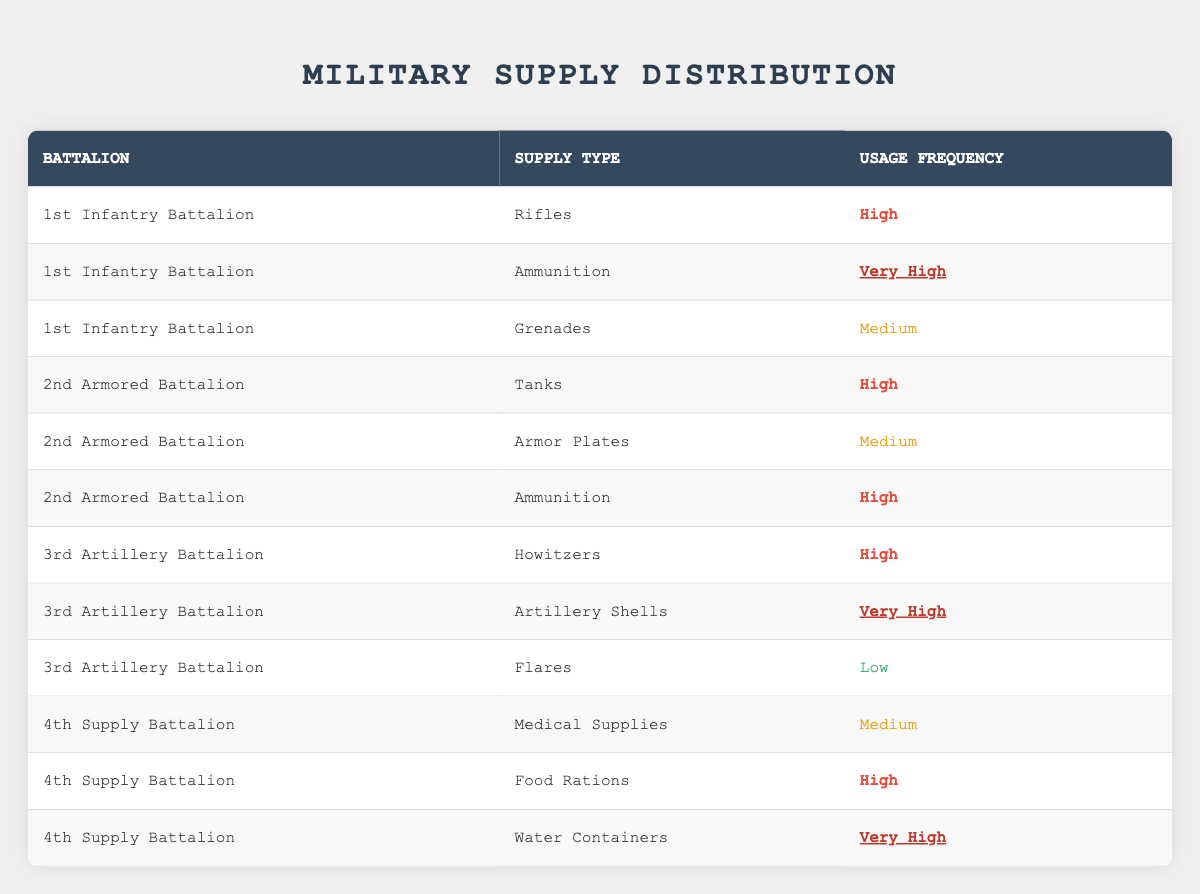What is the usage frequency of ammunition in the 1st Infantry Battalion? Looking at the table, the 1st Infantry Battalion has ammunition listed with a usage frequency marked as "Very High."
Answer: Very High How many different supply types are listed for the 2nd Armored Battalion? The 2nd Armored Battalion has three different supply types: Tanks, Armor Plates, and Ammunition, as seen in the table.
Answer: 3 Is there any supply type with a usage frequency labeled as "Low"? Yes, the 3rd Artillery Battalion has Flares listed with a usage frequency of "Low" in the table.
Answer: Yes How many battalions have high usage frequency for their supplies? Reviewing the table, the battalions with high usage frequency are the 1st Infantry Battalion (Rifles), 2nd Armored Battalion (Tanks and Ammunition), 3rd Artillery Battalion (Howitzers), and 4th Supply Battalion (Food Rations). This makes a total of 5 instances of high usage across 4 battalions.
Answer: 4 Which battalion uses "Water Containers" and what is its usage frequency? From the table, the 4th Supply Battalion uses "Water Containers," and the usage frequency is classified as "Very High." This information can be directly referenced in the table.
Answer: 4th Supply Battalion, Very High What is the total number of medium usage supplies across all battalions? In the table, medium usage supplies are Grenades (1st Infantry Battalion), Armor Plates (2nd Armored Battalion), Medical Supplies (4th Supply Battalion). Adding these gives us three instances of medium usage across different battalions. Therefore, the total number of medium usage supplies is 3.
Answer: 3 Are there any supplies rated as "Very High" used by the 3rd Artillery Battalion? Yes, the 3rd Artillery Battalion uses "Artillery Shells" with a usage frequency marked as "Very High," as listed in the table.
Answer: Yes Which battalion has the highest variety of supply usage frequency listed? A comparative analysis of the table shows that the 1st Infantry Battalion has three supplies with varying usage frequencies (High, Very High, Medium), while others have a maximum of three types but not with the varied frequency levels. Hence, the 1st Infantry Battalion leads in the highest variety of supply usage frequency.
Answer: 1st Infantry Battalion What is the average usage frequency rating for the supplies listed in the 4th Supply Battalion? The 4th Supply Battalion has three supplies: Medical Supplies (Medium), Food Rations (High), and Water Containers (Very High). The weighted average of these frequencies, with Medium at 1, High at 2, and Very High at 3, calculates to (1 + 2 + 3)/3 = 2, which corresponds to an average rating of High.
Answer: High 